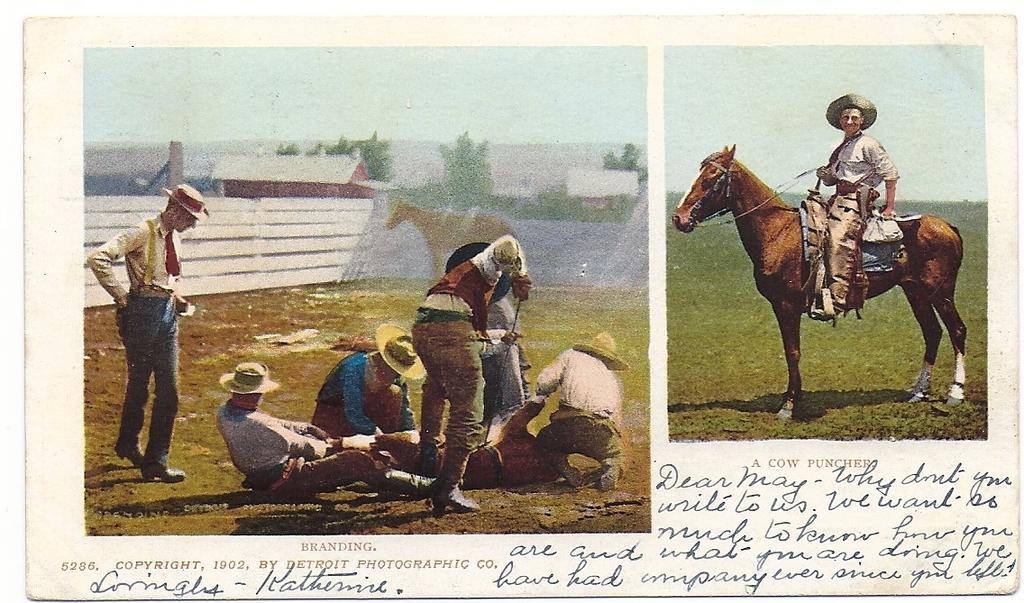What can be seen on the left side of the image? There is a group of people on the left side of the image. What is happening on the right side of the image? There is a person on a horse on the right side of the image. What information is provided at the bottom of the image? There is text written at the bottom of the image. Can you see any oranges in the image? There is no mention of oranges in the provided facts, and therefore we cannot determine if they are present in the image. Is the person on the horse a farmer? The provided facts do not mention the occupation of the person on the horse, so we cannot determine if they are a farmer. 